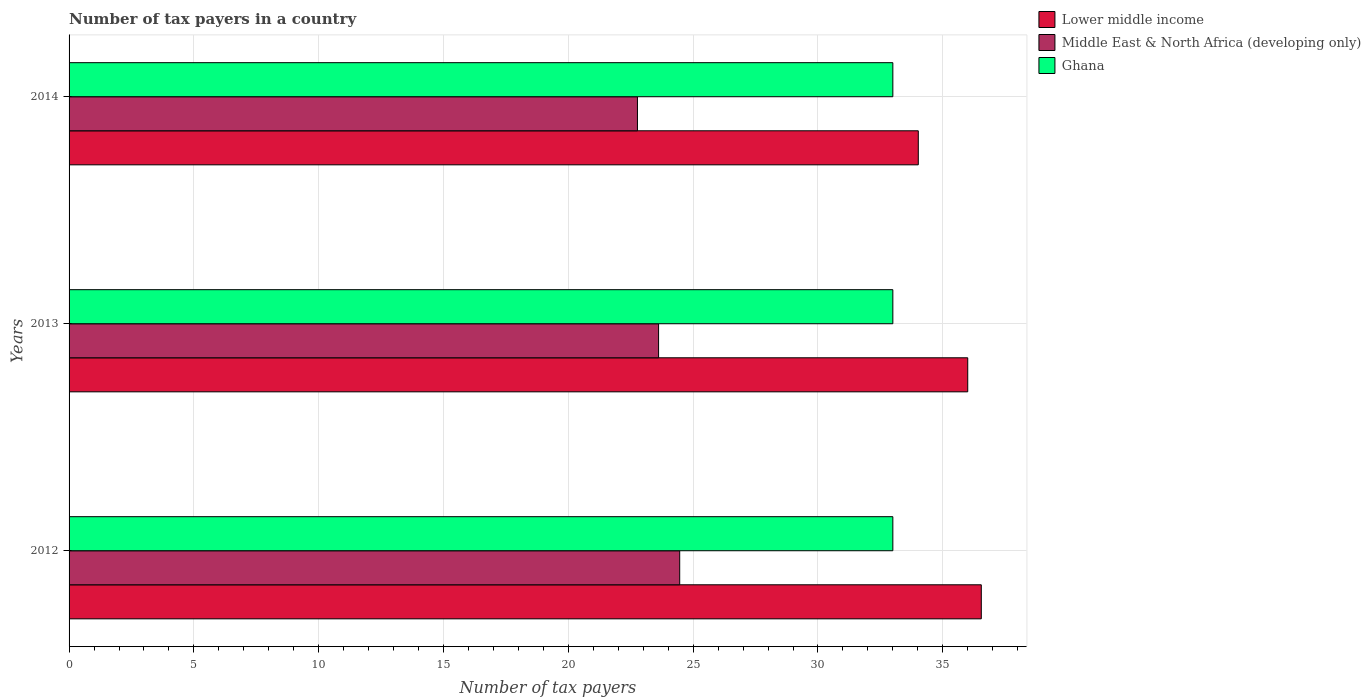How many groups of bars are there?
Offer a very short reply. 3. Are the number of bars per tick equal to the number of legend labels?
Provide a succinct answer. Yes. Are the number of bars on each tick of the Y-axis equal?
Your answer should be compact. Yes. How many bars are there on the 1st tick from the top?
Your answer should be compact. 3. How many bars are there on the 3rd tick from the bottom?
Your answer should be very brief. 3. What is the label of the 3rd group of bars from the top?
Your answer should be very brief. 2012. In how many cases, is the number of bars for a given year not equal to the number of legend labels?
Offer a very short reply. 0. What is the number of tax payers in in Middle East & North Africa (developing only) in 2014?
Offer a very short reply. 22.77. Across all years, what is the maximum number of tax payers in in Lower middle income?
Keep it short and to the point. 36.54. Across all years, what is the minimum number of tax payers in in Lower middle income?
Make the answer very short. 34.02. What is the total number of tax payers in in Lower middle income in the graph?
Your answer should be very brief. 106.56. What is the difference between the number of tax payers in in Ghana in 2014 and the number of tax payers in in Lower middle income in 2012?
Your answer should be very brief. -3.54. What is the average number of tax payers in in Middle East & North Africa (developing only) per year?
Ensure brevity in your answer.  23.62. In the year 2012, what is the difference between the number of tax payers in in Middle East & North Africa (developing only) and number of tax payers in in Ghana?
Offer a very short reply. -8.54. What is the ratio of the number of tax payers in in Lower middle income in 2012 to that in 2013?
Make the answer very short. 1.02. Is the number of tax payers in in Ghana in 2013 less than that in 2014?
Offer a terse response. No. What is the difference between the highest and the second highest number of tax payers in in Middle East & North Africa (developing only)?
Provide a succinct answer. 0.85. In how many years, is the number of tax payers in in Ghana greater than the average number of tax payers in in Ghana taken over all years?
Provide a short and direct response. 0. What does the 1st bar from the bottom in 2014 represents?
Your answer should be compact. Lower middle income. Is it the case that in every year, the sum of the number of tax payers in in Lower middle income and number of tax payers in in Ghana is greater than the number of tax payers in in Middle East & North Africa (developing only)?
Provide a short and direct response. Yes. How many bars are there?
Ensure brevity in your answer.  9. What is the difference between two consecutive major ticks on the X-axis?
Your response must be concise. 5. Are the values on the major ticks of X-axis written in scientific E-notation?
Offer a very short reply. No. Does the graph contain any zero values?
Make the answer very short. No. Does the graph contain grids?
Ensure brevity in your answer.  Yes. How are the legend labels stacked?
Make the answer very short. Vertical. What is the title of the graph?
Your response must be concise. Number of tax payers in a country. Does "Gabon" appear as one of the legend labels in the graph?
Keep it short and to the point. No. What is the label or title of the X-axis?
Ensure brevity in your answer.  Number of tax payers. What is the Number of tax payers of Lower middle income in 2012?
Offer a terse response. 36.54. What is the Number of tax payers in Middle East & North Africa (developing only) in 2012?
Your answer should be very brief. 24.46. What is the Number of tax payers of Ghana in 2012?
Offer a terse response. 33. What is the Number of tax payers of Middle East & North Africa (developing only) in 2013?
Ensure brevity in your answer.  23.62. What is the Number of tax payers of Ghana in 2013?
Your response must be concise. 33. What is the Number of tax payers in Lower middle income in 2014?
Ensure brevity in your answer.  34.02. What is the Number of tax payers in Middle East & North Africa (developing only) in 2014?
Provide a short and direct response. 22.77. Across all years, what is the maximum Number of tax payers of Lower middle income?
Your answer should be compact. 36.54. Across all years, what is the maximum Number of tax payers of Middle East & North Africa (developing only)?
Offer a very short reply. 24.46. Across all years, what is the minimum Number of tax payers in Lower middle income?
Your answer should be very brief. 34.02. Across all years, what is the minimum Number of tax payers of Middle East & North Africa (developing only)?
Keep it short and to the point. 22.77. Across all years, what is the minimum Number of tax payers of Ghana?
Provide a succinct answer. 33. What is the total Number of tax payers in Lower middle income in the graph?
Keep it short and to the point. 106.56. What is the total Number of tax payers in Middle East & North Africa (developing only) in the graph?
Your response must be concise. 70.85. What is the total Number of tax payers of Ghana in the graph?
Provide a succinct answer. 99. What is the difference between the Number of tax payers in Lower middle income in 2012 and that in 2013?
Your answer should be compact. 0.54. What is the difference between the Number of tax payers of Middle East & North Africa (developing only) in 2012 and that in 2013?
Your answer should be very brief. 0.85. What is the difference between the Number of tax payers in Ghana in 2012 and that in 2013?
Make the answer very short. 0. What is the difference between the Number of tax payers in Lower middle income in 2012 and that in 2014?
Your response must be concise. 2.52. What is the difference between the Number of tax payers in Middle East & North Africa (developing only) in 2012 and that in 2014?
Make the answer very short. 1.69. What is the difference between the Number of tax payers of Ghana in 2012 and that in 2014?
Your answer should be compact. 0. What is the difference between the Number of tax payers of Lower middle income in 2013 and that in 2014?
Make the answer very short. 1.98. What is the difference between the Number of tax payers of Middle East & North Africa (developing only) in 2013 and that in 2014?
Your response must be concise. 0.85. What is the difference between the Number of tax payers of Ghana in 2013 and that in 2014?
Your response must be concise. 0. What is the difference between the Number of tax payers of Lower middle income in 2012 and the Number of tax payers of Middle East & North Africa (developing only) in 2013?
Give a very brief answer. 12.93. What is the difference between the Number of tax payers in Lower middle income in 2012 and the Number of tax payers in Ghana in 2013?
Ensure brevity in your answer.  3.54. What is the difference between the Number of tax payers in Middle East & North Africa (developing only) in 2012 and the Number of tax payers in Ghana in 2013?
Ensure brevity in your answer.  -8.54. What is the difference between the Number of tax payers in Lower middle income in 2012 and the Number of tax payers in Middle East & North Africa (developing only) in 2014?
Offer a very short reply. 13.77. What is the difference between the Number of tax payers in Lower middle income in 2012 and the Number of tax payers in Ghana in 2014?
Give a very brief answer. 3.54. What is the difference between the Number of tax payers in Middle East & North Africa (developing only) in 2012 and the Number of tax payers in Ghana in 2014?
Make the answer very short. -8.54. What is the difference between the Number of tax payers in Lower middle income in 2013 and the Number of tax payers in Middle East & North Africa (developing only) in 2014?
Provide a short and direct response. 13.23. What is the difference between the Number of tax payers of Lower middle income in 2013 and the Number of tax payers of Ghana in 2014?
Keep it short and to the point. 3. What is the difference between the Number of tax payers in Middle East & North Africa (developing only) in 2013 and the Number of tax payers in Ghana in 2014?
Provide a short and direct response. -9.38. What is the average Number of tax payers of Lower middle income per year?
Offer a very short reply. 35.52. What is the average Number of tax payers of Middle East & North Africa (developing only) per year?
Provide a succinct answer. 23.62. What is the average Number of tax payers in Ghana per year?
Your answer should be compact. 33. In the year 2012, what is the difference between the Number of tax payers in Lower middle income and Number of tax payers in Middle East & North Africa (developing only)?
Provide a succinct answer. 12.08. In the year 2012, what is the difference between the Number of tax payers in Lower middle income and Number of tax payers in Ghana?
Your response must be concise. 3.54. In the year 2012, what is the difference between the Number of tax payers in Middle East & North Africa (developing only) and Number of tax payers in Ghana?
Make the answer very short. -8.54. In the year 2013, what is the difference between the Number of tax payers of Lower middle income and Number of tax payers of Middle East & North Africa (developing only)?
Make the answer very short. 12.38. In the year 2013, what is the difference between the Number of tax payers of Middle East & North Africa (developing only) and Number of tax payers of Ghana?
Your answer should be compact. -9.38. In the year 2014, what is the difference between the Number of tax payers in Lower middle income and Number of tax payers in Middle East & North Africa (developing only)?
Offer a very short reply. 11.25. In the year 2014, what is the difference between the Number of tax payers in Lower middle income and Number of tax payers in Ghana?
Provide a short and direct response. 1.02. In the year 2014, what is the difference between the Number of tax payers in Middle East & North Africa (developing only) and Number of tax payers in Ghana?
Provide a short and direct response. -10.23. What is the ratio of the Number of tax payers of Lower middle income in 2012 to that in 2013?
Offer a terse response. 1.02. What is the ratio of the Number of tax payers of Middle East & North Africa (developing only) in 2012 to that in 2013?
Ensure brevity in your answer.  1.04. What is the ratio of the Number of tax payers of Ghana in 2012 to that in 2013?
Keep it short and to the point. 1. What is the ratio of the Number of tax payers of Lower middle income in 2012 to that in 2014?
Offer a terse response. 1.07. What is the ratio of the Number of tax payers of Middle East & North Africa (developing only) in 2012 to that in 2014?
Your answer should be very brief. 1.07. What is the ratio of the Number of tax payers of Lower middle income in 2013 to that in 2014?
Make the answer very short. 1.06. What is the ratio of the Number of tax payers of Middle East & North Africa (developing only) in 2013 to that in 2014?
Keep it short and to the point. 1.04. What is the ratio of the Number of tax payers in Ghana in 2013 to that in 2014?
Give a very brief answer. 1. What is the difference between the highest and the second highest Number of tax payers of Lower middle income?
Your answer should be compact. 0.54. What is the difference between the highest and the second highest Number of tax payers of Middle East & North Africa (developing only)?
Provide a succinct answer. 0.85. What is the difference between the highest and the lowest Number of tax payers in Lower middle income?
Offer a terse response. 2.52. What is the difference between the highest and the lowest Number of tax payers in Middle East & North Africa (developing only)?
Provide a succinct answer. 1.69. 